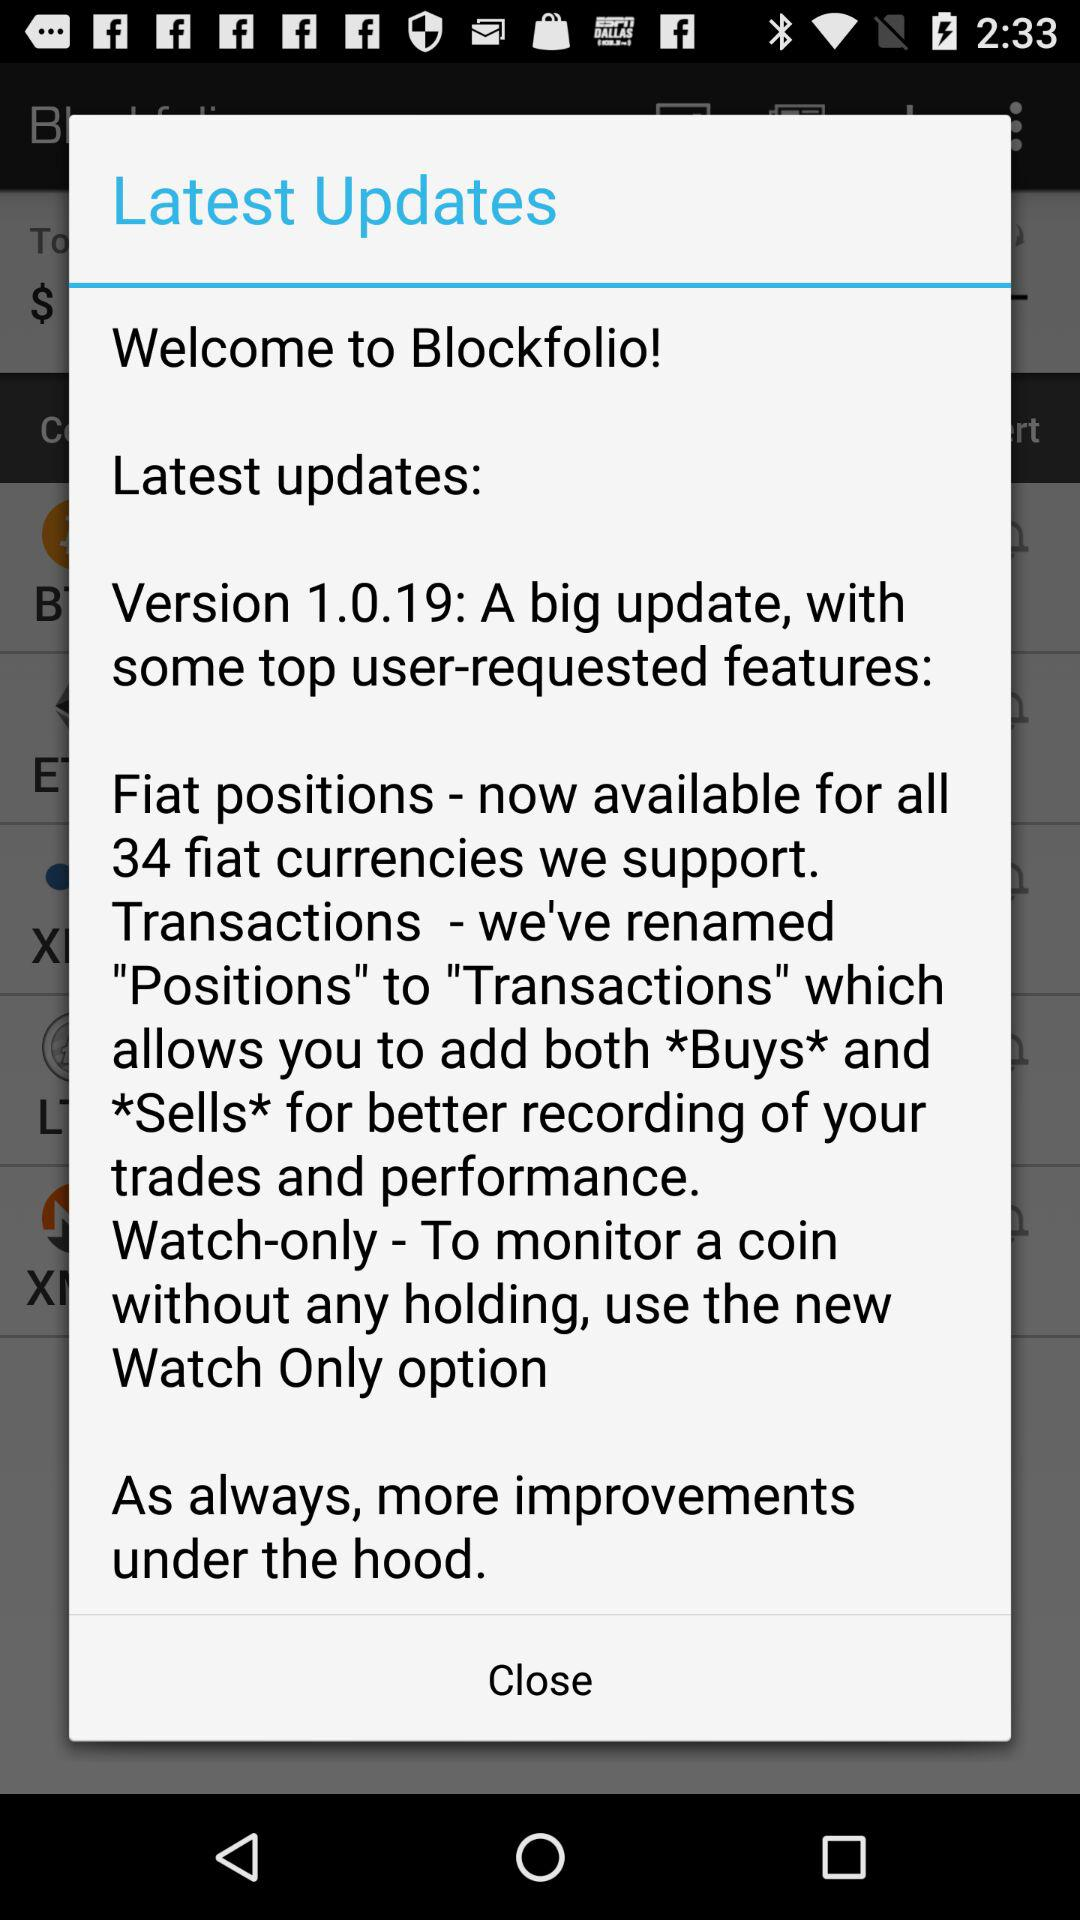How many fiat currencies are supported?
Answer the question using a single word or phrase. 34 